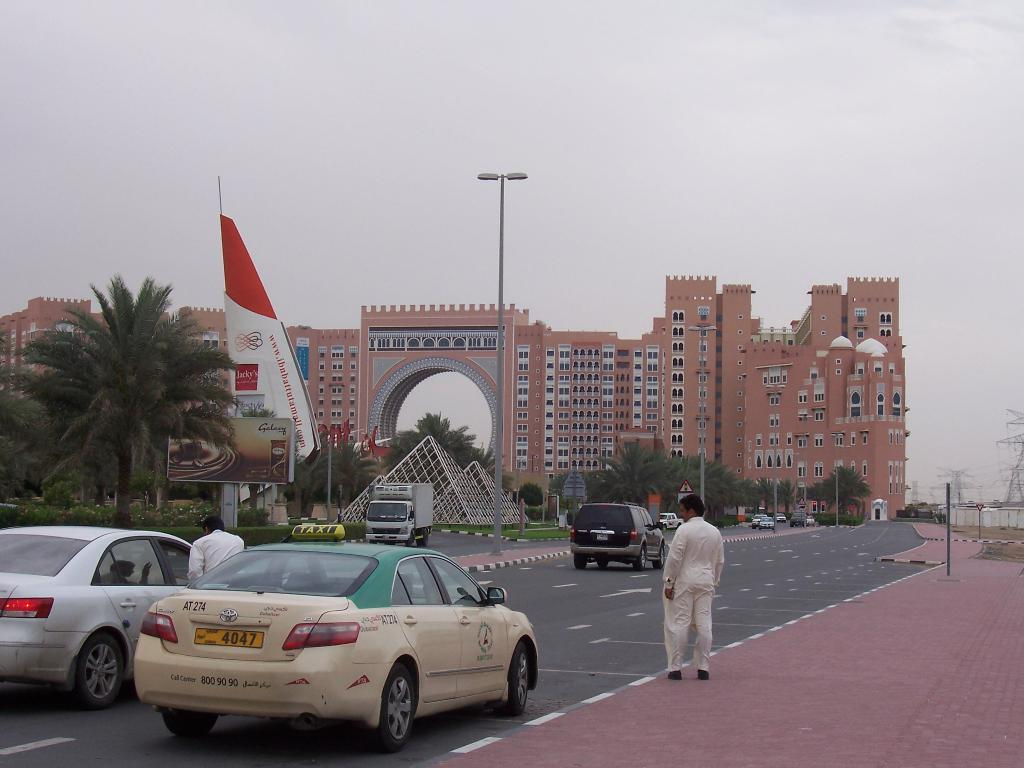<image>
Render a clear and concise summary of the photo. a toyota with license plate 4047 on the street headed towards the building 